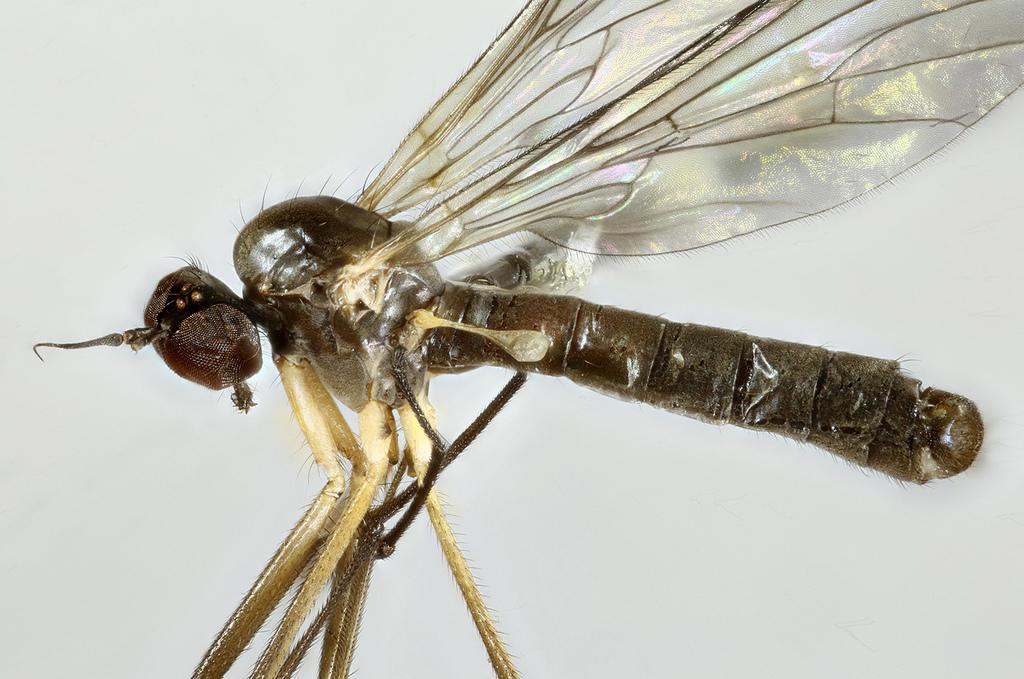What type of creature is present in the image? There is an insect in the image. Can you describe the color pattern of the insect? The insect has a black and cream color. What color can be seen in the background of the image? There is white color visible in the background of the image. What type of drink is being served in the image? There is no drink present in the image; it features an insect with a black and cream color against a white background. What type of cleaning equipment is visible in the image? There is no cleaning equipment present in the image; it features an insect with a black and cream color against a white background. 